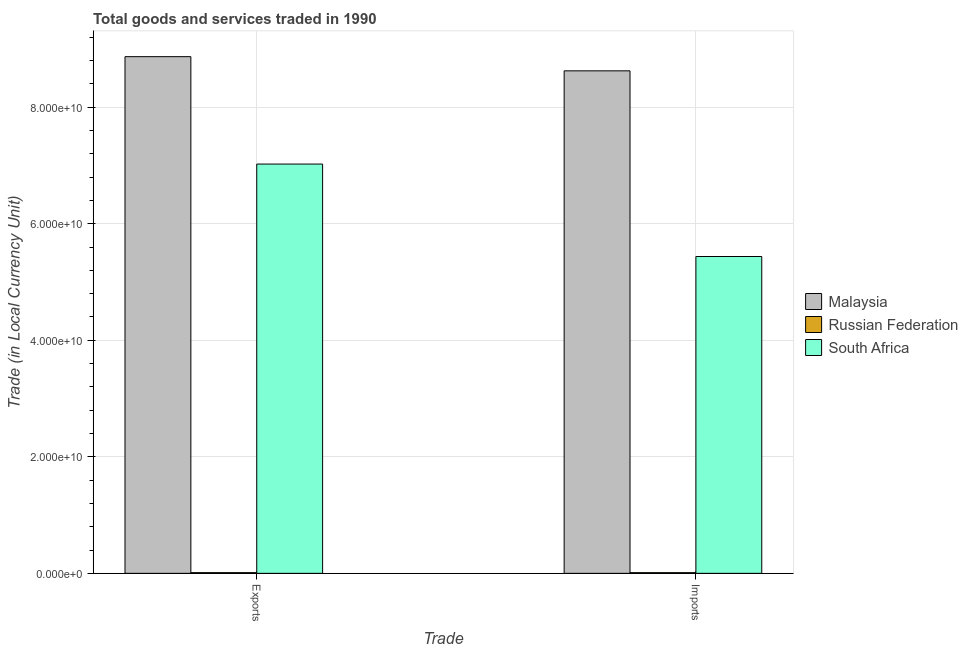Are the number of bars on each tick of the X-axis equal?
Your answer should be very brief. Yes. What is the label of the 1st group of bars from the left?
Provide a succinct answer. Exports. What is the imports of goods and services in South Africa?
Provide a succinct answer. 5.44e+1. Across all countries, what is the maximum export of goods and services?
Your answer should be compact. 8.87e+1. Across all countries, what is the minimum export of goods and services?
Provide a short and direct response. 1.17e+08. In which country was the export of goods and services maximum?
Ensure brevity in your answer.  Malaysia. In which country was the imports of goods and services minimum?
Your answer should be compact. Russian Federation. What is the total imports of goods and services in the graph?
Ensure brevity in your answer.  1.41e+11. What is the difference between the imports of goods and services in South Africa and that in Russian Federation?
Give a very brief answer. 5.43e+1. What is the difference between the export of goods and services in Malaysia and the imports of goods and services in Russian Federation?
Provide a succinct answer. 8.86e+1. What is the average export of goods and services per country?
Provide a succinct answer. 5.30e+1. What is the difference between the export of goods and services and imports of goods and services in South Africa?
Your answer should be compact. 1.59e+1. What is the ratio of the export of goods and services in Russian Federation to that in South Africa?
Make the answer very short. 0. What does the 1st bar from the left in Imports represents?
Your response must be concise. Malaysia. What does the 3rd bar from the right in Imports represents?
Keep it short and to the point. Malaysia. Are all the bars in the graph horizontal?
Offer a very short reply. No. Does the graph contain any zero values?
Provide a short and direct response. No. Does the graph contain grids?
Provide a succinct answer. Yes. Where does the legend appear in the graph?
Give a very brief answer. Center right. How many legend labels are there?
Make the answer very short. 3. What is the title of the graph?
Make the answer very short. Total goods and services traded in 1990. Does "Heavily indebted poor countries" appear as one of the legend labels in the graph?
Offer a very short reply. No. What is the label or title of the X-axis?
Provide a short and direct response. Trade. What is the label or title of the Y-axis?
Your answer should be compact. Trade (in Local Currency Unit). What is the Trade (in Local Currency Unit) of Malaysia in Exports?
Your response must be concise. 8.87e+1. What is the Trade (in Local Currency Unit) of Russian Federation in Exports?
Make the answer very short. 1.17e+08. What is the Trade (in Local Currency Unit) of South Africa in Exports?
Provide a succinct answer. 7.02e+1. What is the Trade (in Local Currency Unit) in Malaysia in Imports?
Give a very brief answer. 8.62e+1. What is the Trade (in Local Currency Unit) in Russian Federation in Imports?
Offer a terse response. 1.16e+08. What is the Trade (in Local Currency Unit) of South Africa in Imports?
Provide a short and direct response. 5.44e+1. Across all Trade, what is the maximum Trade (in Local Currency Unit) of Malaysia?
Make the answer very short. 8.87e+1. Across all Trade, what is the maximum Trade (in Local Currency Unit) in Russian Federation?
Keep it short and to the point. 1.17e+08. Across all Trade, what is the maximum Trade (in Local Currency Unit) in South Africa?
Your response must be concise. 7.02e+1. Across all Trade, what is the minimum Trade (in Local Currency Unit) of Malaysia?
Your answer should be very brief. 8.62e+1. Across all Trade, what is the minimum Trade (in Local Currency Unit) in Russian Federation?
Give a very brief answer. 1.16e+08. Across all Trade, what is the minimum Trade (in Local Currency Unit) of South Africa?
Your response must be concise. 5.44e+1. What is the total Trade (in Local Currency Unit) of Malaysia in the graph?
Provide a short and direct response. 1.75e+11. What is the total Trade (in Local Currency Unit) in Russian Federation in the graph?
Offer a very short reply. 2.33e+08. What is the total Trade (in Local Currency Unit) of South Africa in the graph?
Make the answer very short. 1.25e+11. What is the difference between the Trade (in Local Currency Unit) of Malaysia in Exports and that in Imports?
Ensure brevity in your answer.  2.43e+09. What is the difference between the Trade (in Local Currency Unit) in Russian Federation in Exports and that in Imports?
Your answer should be compact. 1.40e+06. What is the difference between the Trade (in Local Currency Unit) of South Africa in Exports and that in Imports?
Ensure brevity in your answer.  1.59e+1. What is the difference between the Trade (in Local Currency Unit) of Malaysia in Exports and the Trade (in Local Currency Unit) of Russian Federation in Imports?
Ensure brevity in your answer.  8.86e+1. What is the difference between the Trade (in Local Currency Unit) in Malaysia in Exports and the Trade (in Local Currency Unit) in South Africa in Imports?
Provide a succinct answer. 3.43e+1. What is the difference between the Trade (in Local Currency Unit) in Russian Federation in Exports and the Trade (in Local Currency Unit) in South Africa in Imports?
Offer a very short reply. -5.43e+1. What is the average Trade (in Local Currency Unit) of Malaysia per Trade?
Your answer should be very brief. 8.75e+1. What is the average Trade (in Local Currency Unit) in Russian Federation per Trade?
Make the answer very short. 1.16e+08. What is the average Trade (in Local Currency Unit) of South Africa per Trade?
Offer a terse response. 6.23e+1. What is the difference between the Trade (in Local Currency Unit) in Malaysia and Trade (in Local Currency Unit) in Russian Federation in Exports?
Offer a terse response. 8.86e+1. What is the difference between the Trade (in Local Currency Unit) of Malaysia and Trade (in Local Currency Unit) of South Africa in Exports?
Provide a succinct answer. 1.84e+1. What is the difference between the Trade (in Local Currency Unit) in Russian Federation and Trade (in Local Currency Unit) in South Africa in Exports?
Keep it short and to the point. -7.01e+1. What is the difference between the Trade (in Local Currency Unit) of Malaysia and Trade (in Local Currency Unit) of Russian Federation in Imports?
Give a very brief answer. 8.61e+1. What is the difference between the Trade (in Local Currency Unit) in Malaysia and Trade (in Local Currency Unit) in South Africa in Imports?
Give a very brief answer. 3.19e+1. What is the difference between the Trade (in Local Currency Unit) in Russian Federation and Trade (in Local Currency Unit) in South Africa in Imports?
Your response must be concise. -5.43e+1. What is the ratio of the Trade (in Local Currency Unit) in Malaysia in Exports to that in Imports?
Make the answer very short. 1.03. What is the ratio of the Trade (in Local Currency Unit) in Russian Federation in Exports to that in Imports?
Ensure brevity in your answer.  1.01. What is the ratio of the Trade (in Local Currency Unit) of South Africa in Exports to that in Imports?
Provide a succinct answer. 1.29. What is the difference between the highest and the second highest Trade (in Local Currency Unit) in Malaysia?
Your response must be concise. 2.43e+09. What is the difference between the highest and the second highest Trade (in Local Currency Unit) of Russian Federation?
Make the answer very short. 1.40e+06. What is the difference between the highest and the second highest Trade (in Local Currency Unit) in South Africa?
Make the answer very short. 1.59e+1. What is the difference between the highest and the lowest Trade (in Local Currency Unit) in Malaysia?
Your answer should be compact. 2.43e+09. What is the difference between the highest and the lowest Trade (in Local Currency Unit) of Russian Federation?
Keep it short and to the point. 1.40e+06. What is the difference between the highest and the lowest Trade (in Local Currency Unit) of South Africa?
Offer a terse response. 1.59e+1. 